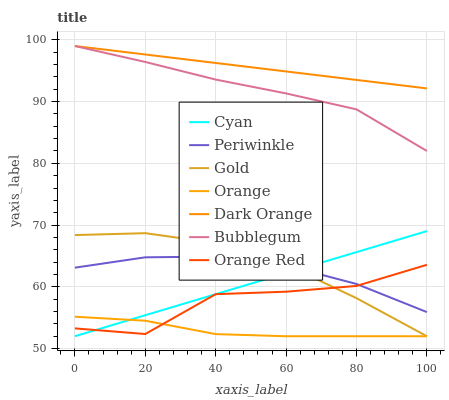Does Gold have the minimum area under the curve?
Answer yes or no. No. Does Gold have the maximum area under the curve?
Answer yes or no. No. Is Gold the smoothest?
Answer yes or no. No. Is Gold the roughest?
Answer yes or no. No. Does Bubblegum have the lowest value?
Answer yes or no. No. Does Gold have the highest value?
Answer yes or no. No. Is Gold less than Bubblegum?
Answer yes or no. Yes. Is Dark Orange greater than Periwinkle?
Answer yes or no. Yes. Does Gold intersect Bubblegum?
Answer yes or no. No. 